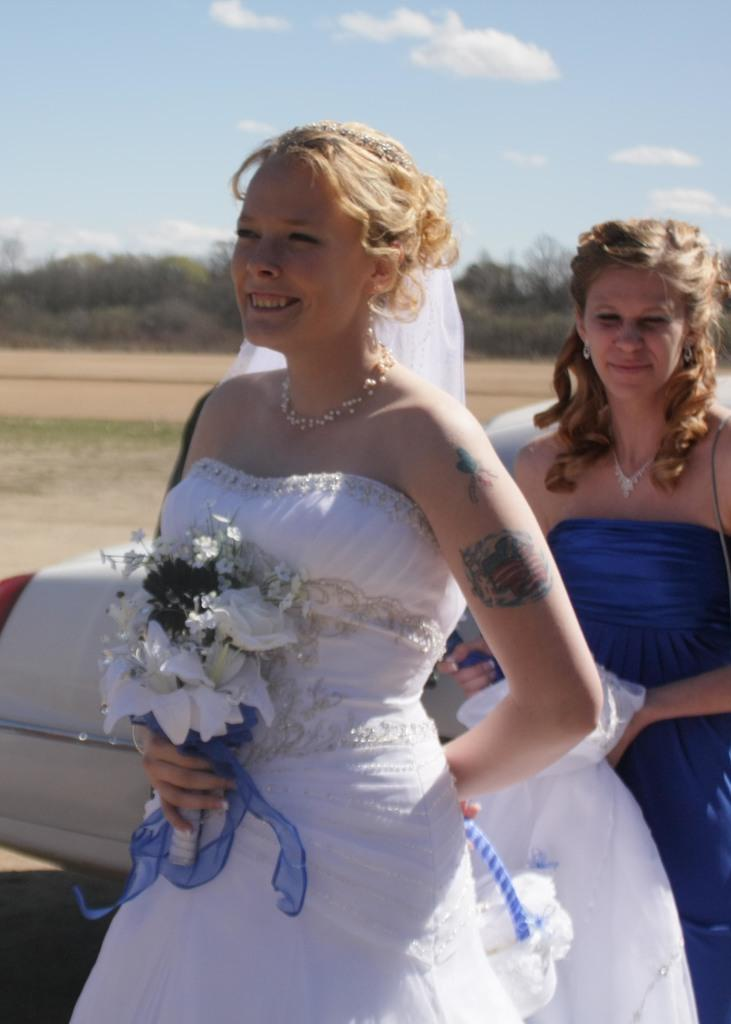How many women are in the image? There are two women in the image. What else can be seen in the image besides the women? There are flowers, a vehicle, trees in the background, and the sky with clouds at the top of the image. Can you describe the vehicle in the image? Unfortunately, the facts provided do not give a detailed description of the vehicle. What type of vegetation is visible in the background of the image? There are trees in the background of the image. What is the plot of the book that the women are reading in the image? There is no book present in the image, so it is not possible to determine the plot of a book being read. 